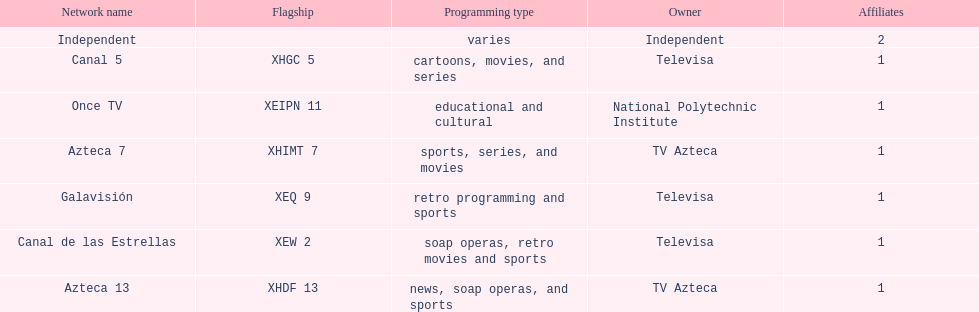Azteca 7 and azteca 13 are both owned by whom? TV Azteca. 